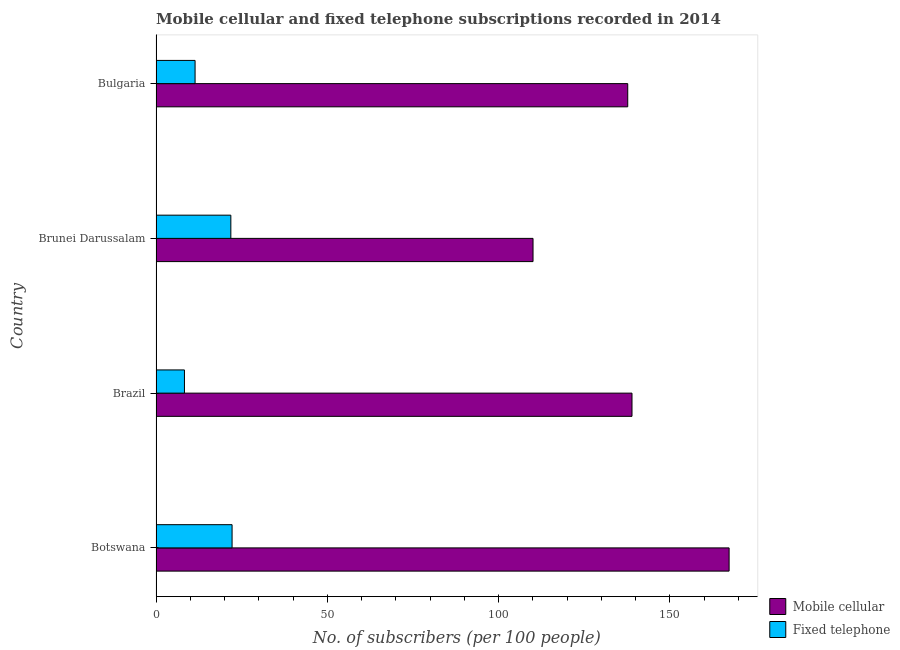Are the number of bars on each tick of the Y-axis equal?
Provide a short and direct response. Yes. How many bars are there on the 1st tick from the bottom?
Provide a short and direct response. 2. What is the label of the 1st group of bars from the top?
Your response must be concise. Bulgaria. In how many cases, is the number of bars for a given country not equal to the number of legend labels?
Ensure brevity in your answer.  0. What is the number of fixed telephone subscribers in Brunei Darussalam?
Provide a short and direct response. 21.84. Across all countries, what is the maximum number of fixed telephone subscribers?
Make the answer very short. 22.2. Across all countries, what is the minimum number of fixed telephone subscribers?
Offer a terse response. 8.3. In which country was the number of fixed telephone subscribers maximum?
Give a very brief answer. Botswana. In which country was the number of mobile cellular subscribers minimum?
Give a very brief answer. Brunei Darussalam. What is the total number of mobile cellular subscribers in the graph?
Provide a succinct answer. 554.01. What is the difference between the number of mobile cellular subscribers in Brazil and that in Bulgaria?
Your response must be concise. 1.25. What is the difference between the number of fixed telephone subscribers in Botswana and the number of mobile cellular subscribers in Brunei Darussalam?
Provide a succinct answer. -87.85. What is the average number of fixed telephone subscribers per country?
Offer a very short reply. 15.94. What is the difference between the number of fixed telephone subscribers and number of mobile cellular subscribers in Botswana?
Ensure brevity in your answer.  -145.09. What is the ratio of the number of mobile cellular subscribers in Botswana to that in Bulgaria?
Your answer should be very brief. 1.22. What is the difference between the highest and the second highest number of mobile cellular subscribers?
Make the answer very short. 28.35. What is the difference between the highest and the lowest number of mobile cellular subscribers?
Offer a very short reply. 57.24. What does the 1st bar from the top in Botswana represents?
Make the answer very short. Fixed telephone. What does the 1st bar from the bottom in Bulgaria represents?
Provide a succinct answer. Mobile cellular. Are all the bars in the graph horizontal?
Give a very brief answer. Yes. Are the values on the major ticks of X-axis written in scientific E-notation?
Provide a succinct answer. No. Does the graph contain grids?
Offer a very short reply. No. Where does the legend appear in the graph?
Your answer should be compact. Bottom right. What is the title of the graph?
Offer a terse response. Mobile cellular and fixed telephone subscriptions recorded in 2014. What is the label or title of the X-axis?
Your response must be concise. No. of subscribers (per 100 people). What is the No. of subscribers (per 100 people) of Mobile cellular in Botswana?
Your response must be concise. 167.3. What is the No. of subscribers (per 100 people) in Fixed telephone in Botswana?
Provide a succinct answer. 22.2. What is the No. of subscribers (per 100 people) of Mobile cellular in Brazil?
Make the answer very short. 138.95. What is the No. of subscribers (per 100 people) of Fixed telephone in Brazil?
Your response must be concise. 8.3. What is the No. of subscribers (per 100 people) of Mobile cellular in Brunei Darussalam?
Give a very brief answer. 110.06. What is the No. of subscribers (per 100 people) of Fixed telephone in Brunei Darussalam?
Keep it short and to the point. 21.84. What is the No. of subscribers (per 100 people) in Mobile cellular in Bulgaria?
Ensure brevity in your answer.  137.71. What is the No. of subscribers (per 100 people) in Fixed telephone in Bulgaria?
Ensure brevity in your answer.  11.4. Across all countries, what is the maximum No. of subscribers (per 100 people) of Mobile cellular?
Ensure brevity in your answer.  167.3. Across all countries, what is the maximum No. of subscribers (per 100 people) in Fixed telephone?
Ensure brevity in your answer.  22.2. Across all countries, what is the minimum No. of subscribers (per 100 people) in Mobile cellular?
Offer a very short reply. 110.06. Across all countries, what is the minimum No. of subscribers (per 100 people) of Fixed telephone?
Give a very brief answer. 8.3. What is the total No. of subscribers (per 100 people) in Mobile cellular in the graph?
Provide a short and direct response. 554.01. What is the total No. of subscribers (per 100 people) in Fixed telephone in the graph?
Provide a succinct answer. 63.75. What is the difference between the No. of subscribers (per 100 people) in Mobile cellular in Botswana and that in Brazil?
Keep it short and to the point. 28.35. What is the difference between the No. of subscribers (per 100 people) in Fixed telephone in Botswana and that in Brazil?
Provide a short and direct response. 13.9. What is the difference between the No. of subscribers (per 100 people) of Mobile cellular in Botswana and that in Brunei Darussalam?
Ensure brevity in your answer.  57.24. What is the difference between the No. of subscribers (per 100 people) of Fixed telephone in Botswana and that in Brunei Darussalam?
Your response must be concise. 0.36. What is the difference between the No. of subscribers (per 100 people) of Mobile cellular in Botswana and that in Bulgaria?
Your answer should be compact. 29.59. What is the difference between the No. of subscribers (per 100 people) in Fixed telephone in Botswana and that in Bulgaria?
Give a very brief answer. 10.8. What is the difference between the No. of subscribers (per 100 people) of Mobile cellular in Brazil and that in Brunei Darussalam?
Give a very brief answer. 28.89. What is the difference between the No. of subscribers (per 100 people) of Fixed telephone in Brazil and that in Brunei Darussalam?
Provide a succinct answer. -13.54. What is the difference between the No. of subscribers (per 100 people) in Mobile cellular in Brazil and that in Bulgaria?
Make the answer very short. 1.24. What is the difference between the No. of subscribers (per 100 people) in Fixed telephone in Brazil and that in Bulgaria?
Offer a very short reply. -3.1. What is the difference between the No. of subscribers (per 100 people) of Mobile cellular in Brunei Darussalam and that in Bulgaria?
Provide a short and direct response. -27.65. What is the difference between the No. of subscribers (per 100 people) of Fixed telephone in Brunei Darussalam and that in Bulgaria?
Your answer should be compact. 10.44. What is the difference between the No. of subscribers (per 100 people) in Mobile cellular in Botswana and the No. of subscribers (per 100 people) in Fixed telephone in Brazil?
Provide a short and direct response. 159. What is the difference between the No. of subscribers (per 100 people) in Mobile cellular in Botswana and the No. of subscribers (per 100 people) in Fixed telephone in Brunei Darussalam?
Offer a terse response. 145.46. What is the difference between the No. of subscribers (per 100 people) of Mobile cellular in Botswana and the No. of subscribers (per 100 people) of Fixed telephone in Bulgaria?
Give a very brief answer. 155.9. What is the difference between the No. of subscribers (per 100 people) in Mobile cellular in Brazil and the No. of subscribers (per 100 people) in Fixed telephone in Brunei Darussalam?
Keep it short and to the point. 117.11. What is the difference between the No. of subscribers (per 100 people) of Mobile cellular in Brazil and the No. of subscribers (per 100 people) of Fixed telephone in Bulgaria?
Ensure brevity in your answer.  127.55. What is the difference between the No. of subscribers (per 100 people) in Mobile cellular in Brunei Darussalam and the No. of subscribers (per 100 people) in Fixed telephone in Bulgaria?
Your answer should be very brief. 98.66. What is the average No. of subscribers (per 100 people) in Mobile cellular per country?
Your answer should be compact. 138.5. What is the average No. of subscribers (per 100 people) in Fixed telephone per country?
Your answer should be compact. 15.94. What is the difference between the No. of subscribers (per 100 people) of Mobile cellular and No. of subscribers (per 100 people) of Fixed telephone in Botswana?
Ensure brevity in your answer.  145.09. What is the difference between the No. of subscribers (per 100 people) in Mobile cellular and No. of subscribers (per 100 people) in Fixed telephone in Brazil?
Provide a short and direct response. 130.65. What is the difference between the No. of subscribers (per 100 people) of Mobile cellular and No. of subscribers (per 100 people) of Fixed telephone in Brunei Darussalam?
Keep it short and to the point. 88.22. What is the difference between the No. of subscribers (per 100 people) in Mobile cellular and No. of subscribers (per 100 people) in Fixed telephone in Bulgaria?
Your answer should be very brief. 126.31. What is the ratio of the No. of subscribers (per 100 people) in Mobile cellular in Botswana to that in Brazil?
Your response must be concise. 1.2. What is the ratio of the No. of subscribers (per 100 people) of Fixed telephone in Botswana to that in Brazil?
Ensure brevity in your answer.  2.67. What is the ratio of the No. of subscribers (per 100 people) in Mobile cellular in Botswana to that in Brunei Darussalam?
Provide a succinct answer. 1.52. What is the ratio of the No. of subscribers (per 100 people) in Fixed telephone in Botswana to that in Brunei Darussalam?
Provide a succinct answer. 1.02. What is the ratio of the No. of subscribers (per 100 people) of Mobile cellular in Botswana to that in Bulgaria?
Offer a terse response. 1.21. What is the ratio of the No. of subscribers (per 100 people) of Fixed telephone in Botswana to that in Bulgaria?
Your response must be concise. 1.95. What is the ratio of the No. of subscribers (per 100 people) of Mobile cellular in Brazil to that in Brunei Darussalam?
Provide a short and direct response. 1.26. What is the ratio of the No. of subscribers (per 100 people) of Fixed telephone in Brazil to that in Brunei Darussalam?
Keep it short and to the point. 0.38. What is the ratio of the No. of subscribers (per 100 people) of Fixed telephone in Brazil to that in Bulgaria?
Make the answer very short. 0.73. What is the ratio of the No. of subscribers (per 100 people) of Mobile cellular in Brunei Darussalam to that in Bulgaria?
Provide a succinct answer. 0.8. What is the ratio of the No. of subscribers (per 100 people) of Fixed telephone in Brunei Darussalam to that in Bulgaria?
Your answer should be compact. 1.92. What is the difference between the highest and the second highest No. of subscribers (per 100 people) of Mobile cellular?
Offer a terse response. 28.35. What is the difference between the highest and the second highest No. of subscribers (per 100 people) in Fixed telephone?
Provide a succinct answer. 0.36. What is the difference between the highest and the lowest No. of subscribers (per 100 people) in Mobile cellular?
Ensure brevity in your answer.  57.24. What is the difference between the highest and the lowest No. of subscribers (per 100 people) in Fixed telephone?
Keep it short and to the point. 13.9. 